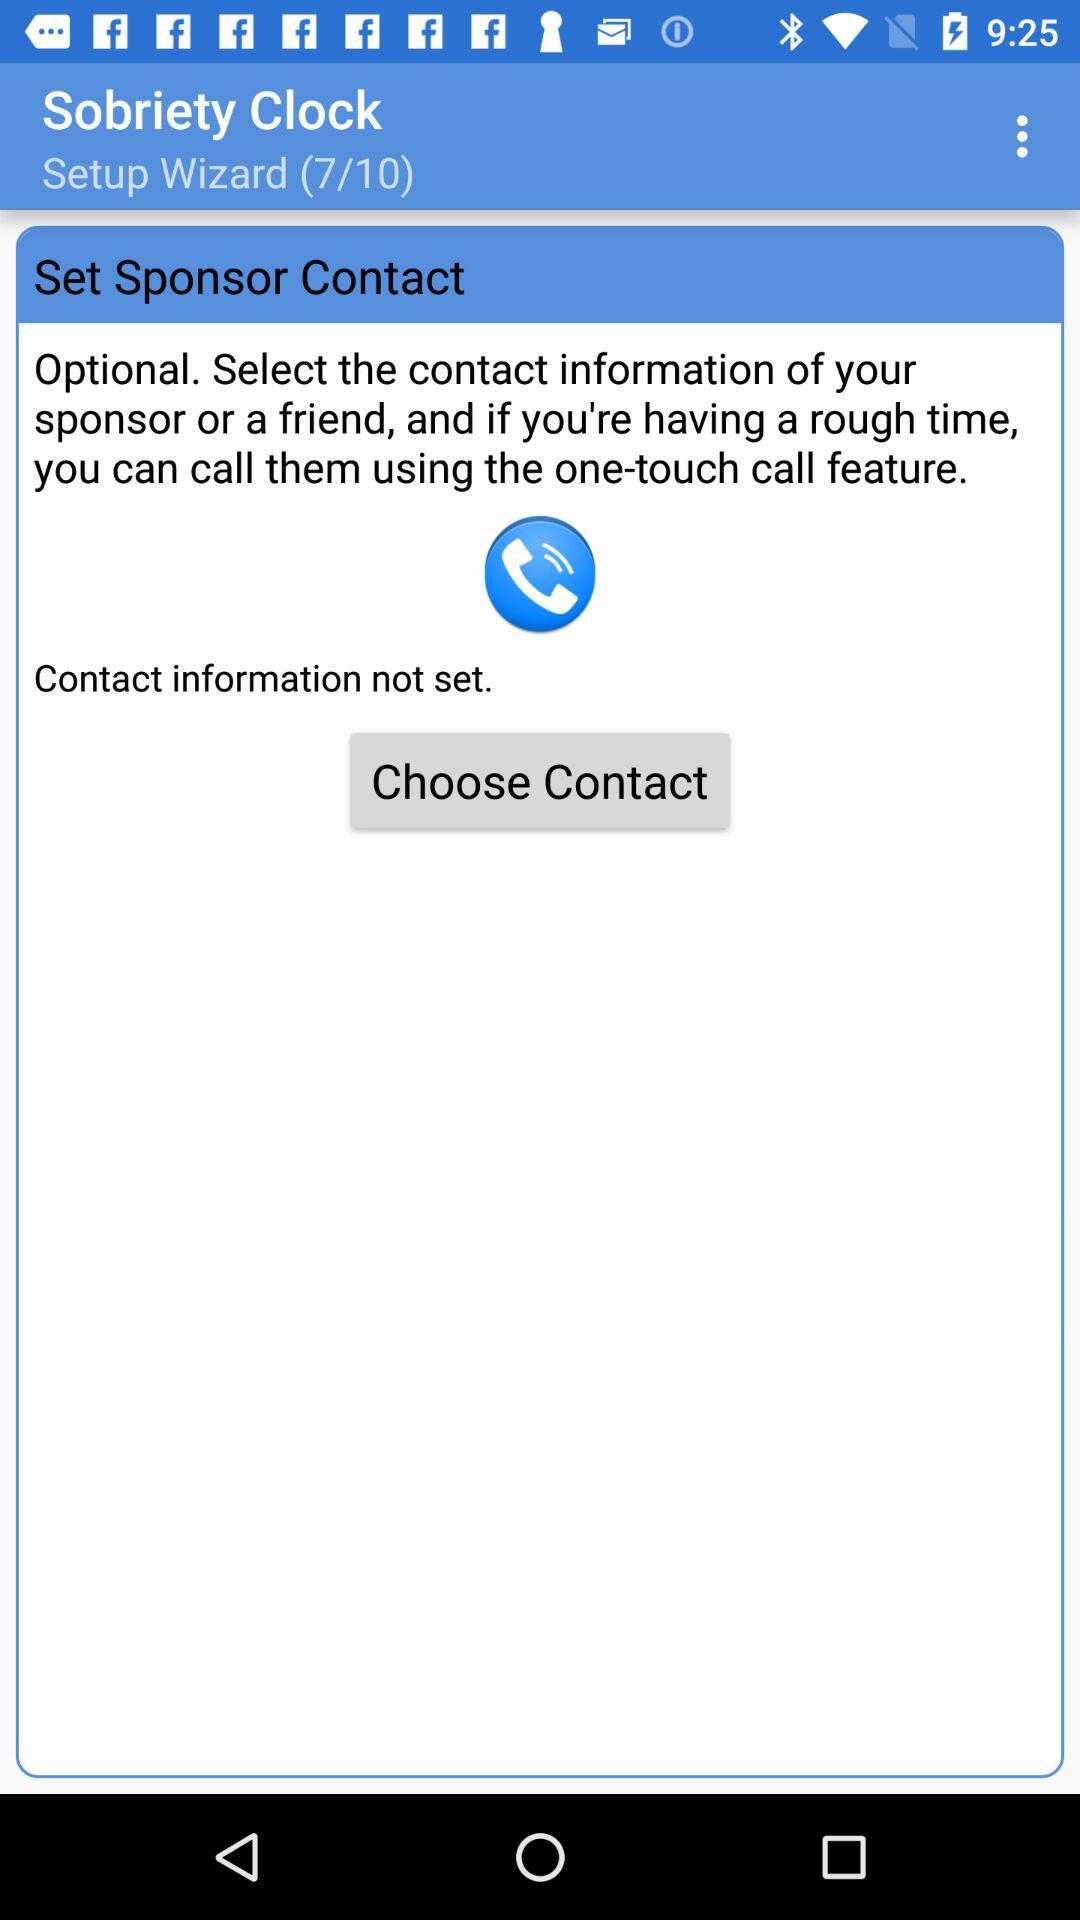What is the number of steps in the "Setup Wizard"? The number of steps in the "Setup Wizard" is 10. 